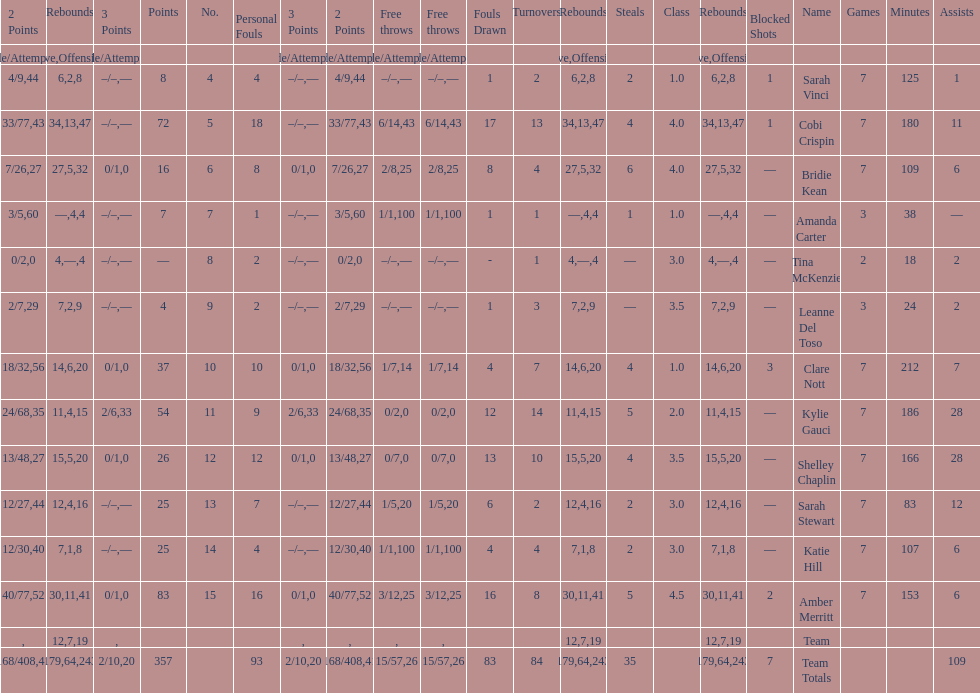Which player had the most total points? Amber Merritt. 